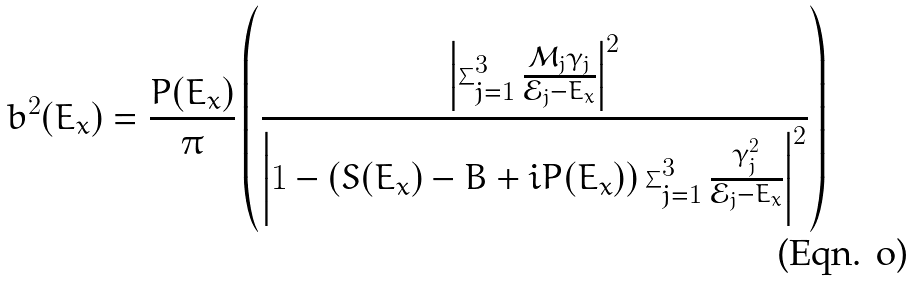<formula> <loc_0><loc_0><loc_500><loc_500>b ^ { 2 } ( E _ { x } ) = \frac { P ( E _ { x } ) } { \pi } \left ( \frac { \left | \sum _ { j = 1 } ^ { 3 } \frac { \mathcal { M } _ { j } \gamma _ { j } } { \mathcal { E } _ { j } - E _ { x } } \right | ^ { 2 } } { \left | 1 - \left ( S ( E _ { x } ) - B + i P ( E _ { x } ) \right ) \sum _ { j = 1 } ^ { 3 } \frac { \gamma _ { j } ^ { 2 } } { \mathcal { E } _ { j } - E _ { x } } \right | ^ { 2 } } \right )</formula> 